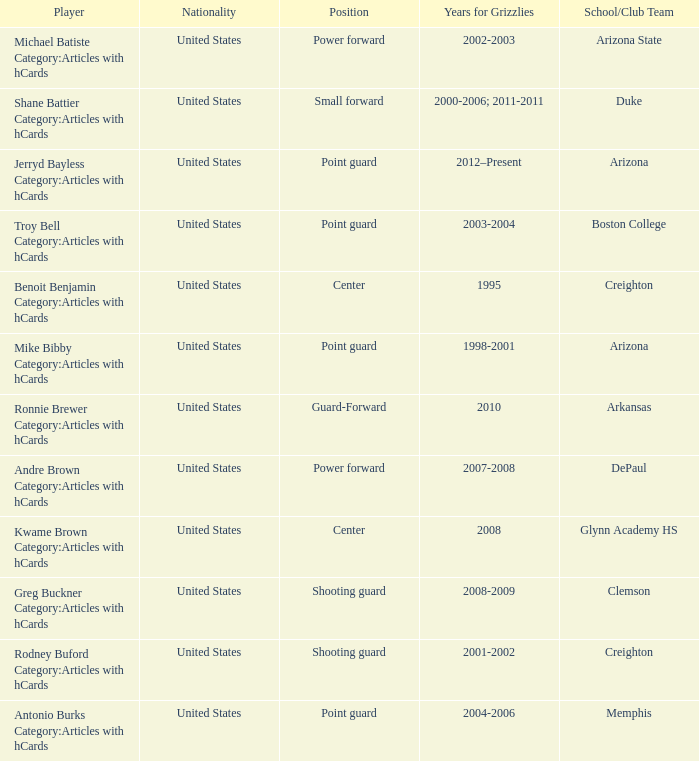Which Player has Years for Grizzlies of 2002-2003? Michael Batiste Category:Articles with hCards. 